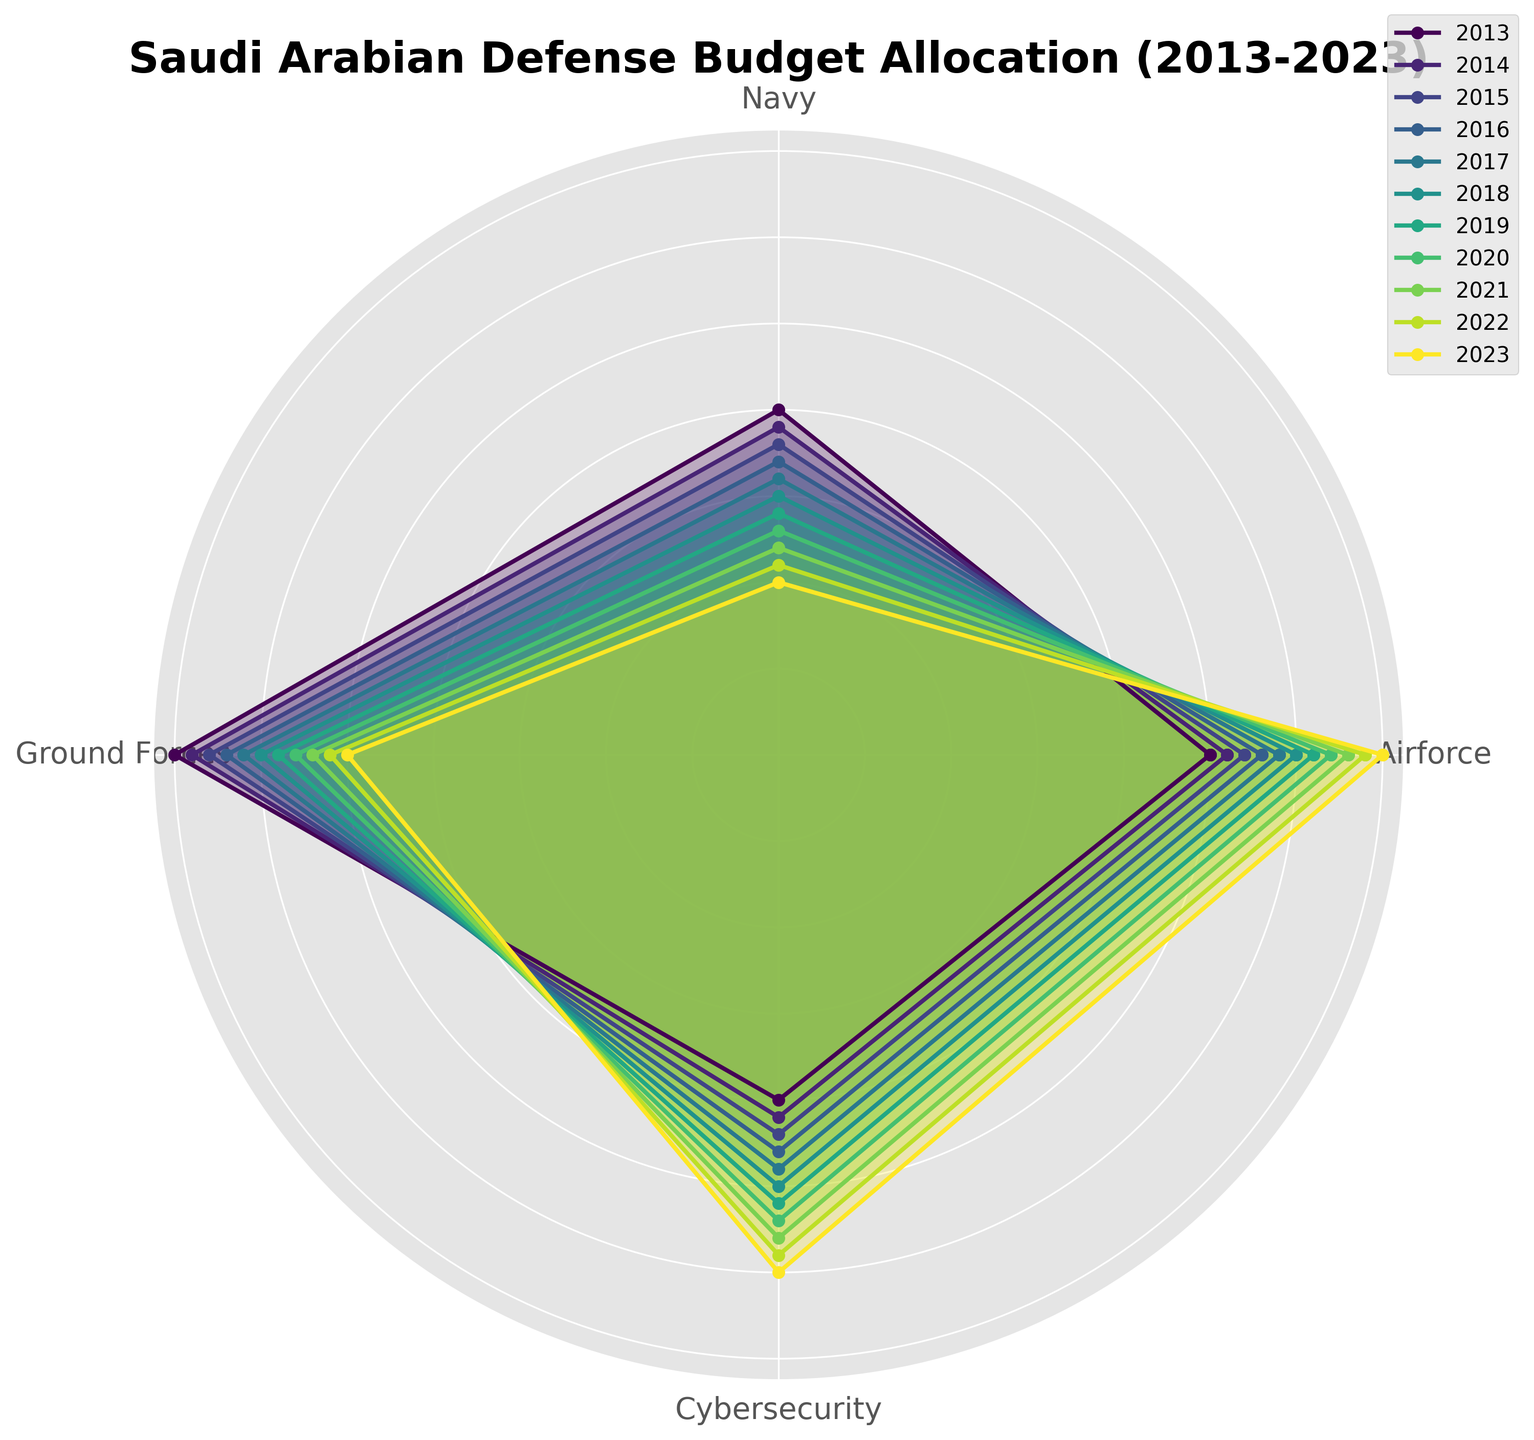How does the allocation percentage of the Airforce in 2023 compare to 2013? In 2023, the Airforce allocation percentage is 35%, while in 2013 it was 25%. Therefore, the allocation has increased by 10 percentage points.
Answer: Increased by 10 percentage points Which sector has seen the most significant increase in budget allocation over the last decade? By visually examining the rose chart, it is clear that the Cybersecurity sector has observed a substantial increase from 20% in 2013 to 30% in 2023, which is the largest increase among the sectors.
Answer: Cybersecurity Compare the allocations for the Ground Forces and Navy in 2020. Which sector received more, and by how much? In 2020, the Ground Forces received 28% of the budget, while the Navy received 13%. The Ground Forces received 15 percentage points more than the Navy.
Answer: Ground Forces; 15 percentage points more What trend do you observe in the budget allocation for the Navy from 2013 to 2023? The rose chart shows a consistent downward trend in the Navy's budget allocation, decreasing from 20% in 2013 to 10% in 2023.
Answer: Downward trend Calculate the total percentage allocation for the Airforce and Cybersecurity sectors in 2019. In 2019, the allocation percentages were 31% for Airforce and 26% for Cybersecurity. Therefore, the total allocation is 31% + 26% = 57%.
Answer: 57% Which year had the highest combined allocation for the Ground Forces and Cybersecurity? By examining the lengths of the segments in the rose chart, 2023 had the highest combined allocation: 25% (Ground Forces) + 30% (Cybersecurity) = 55%.
Answer: 2023 Is there a year where the Airforce allocation surpasses the combined allocation of the Ground Forces and Navy? In 2023, the Airforce allocation is 35%, while the combined allocation of Ground Forces (25%) and Navy (10%) is 35%. Therefore, the Airforce does not surpass the combined allocation in any year.
Answer: No Determine the average budget allocation for the Airforce over the 10 years. Sum the yearly allocations for the Airforce from 2013 to 2023: 25% + 26% + 27% + 28% + 29% + 30% + 31% + 32% + 33% + 34% + 35% = 330%. The average allocation is 330% / 11 years = 30%.
Answer: 30% How does the total defense budget allocation change for Cybersecurity from 2013 to 2020? Cybersecurity's allocation increased from 20% in 2013 to 27% in 2020, indicating a rise of 7 percentage points over this period.
Answer: Increased by 7 percentage points 